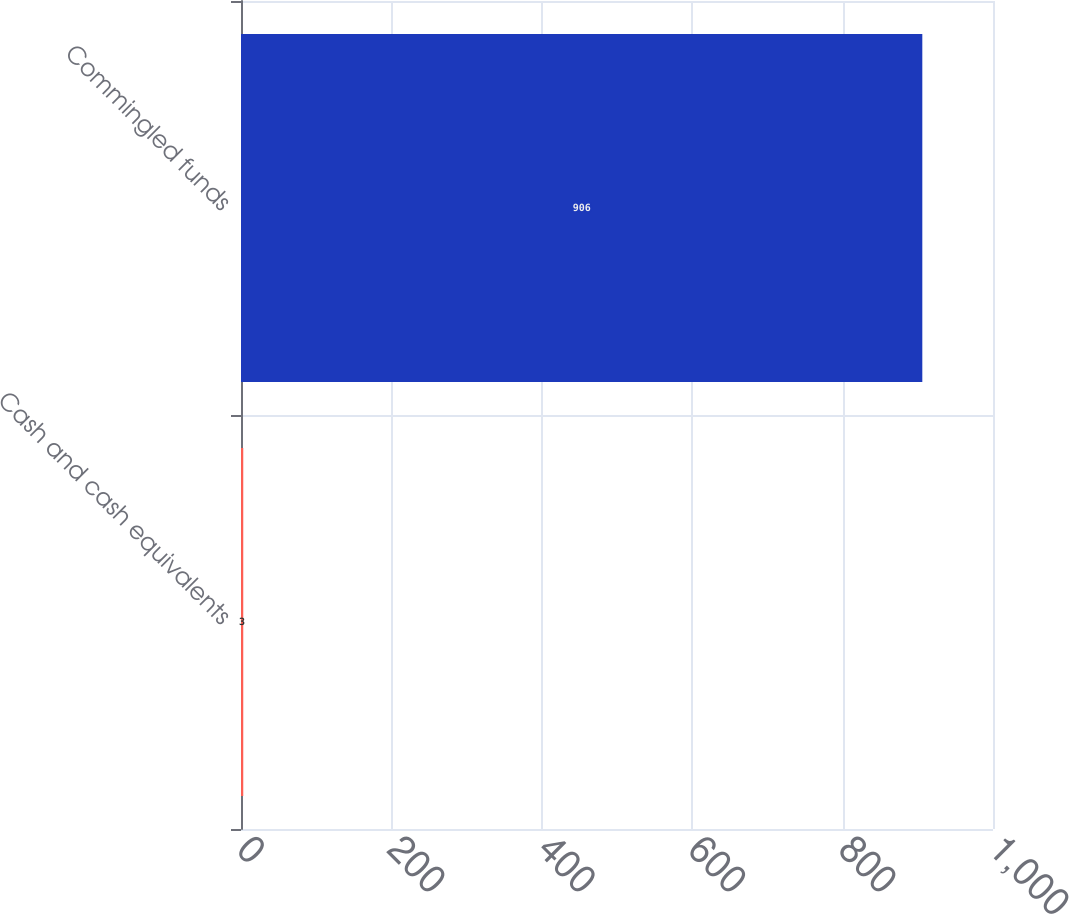Convert chart. <chart><loc_0><loc_0><loc_500><loc_500><bar_chart><fcel>Cash and cash equivalents<fcel>Commingled funds<nl><fcel>3<fcel>906<nl></chart> 